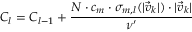<formula> <loc_0><loc_0><loc_500><loc_500>C _ { l } = C _ { l - 1 } + \frac { N \cdot c _ { m } \cdot \sigma _ { m , l } ( | \vec { v } _ { k } | ) \cdot | \vec { v } _ { k } | } { \nu ^ { \prime } }</formula> 